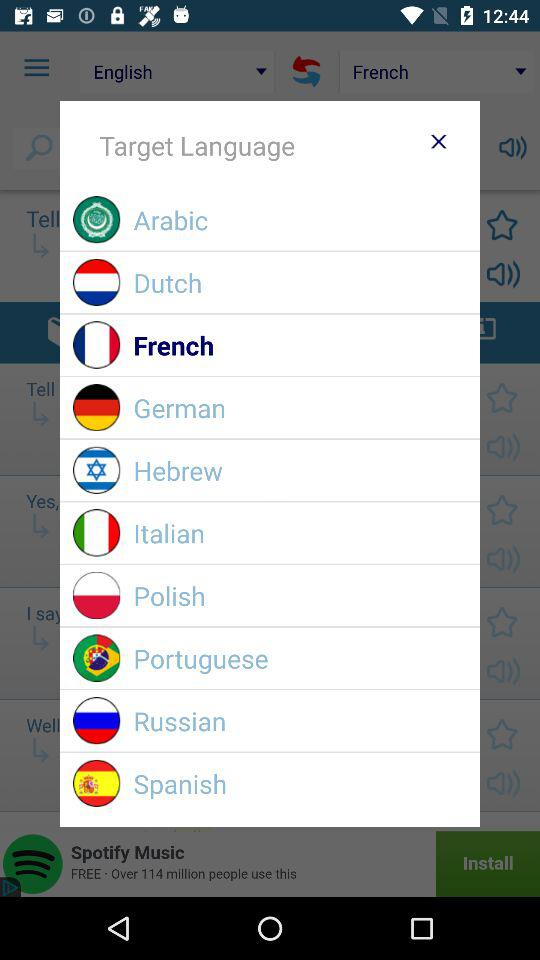What are the available language? The available languages are Arabic, Dutch, French, German, Hebrew, Italian, Polish, Portuguese, Russian and Spanish. 